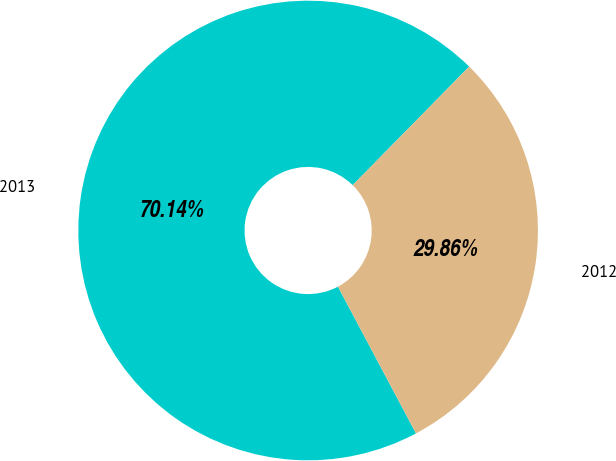Convert chart. <chart><loc_0><loc_0><loc_500><loc_500><pie_chart><fcel>2013<fcel>2012<nl><fcel>70.14%<fcel>29.86%<nl></chart> 